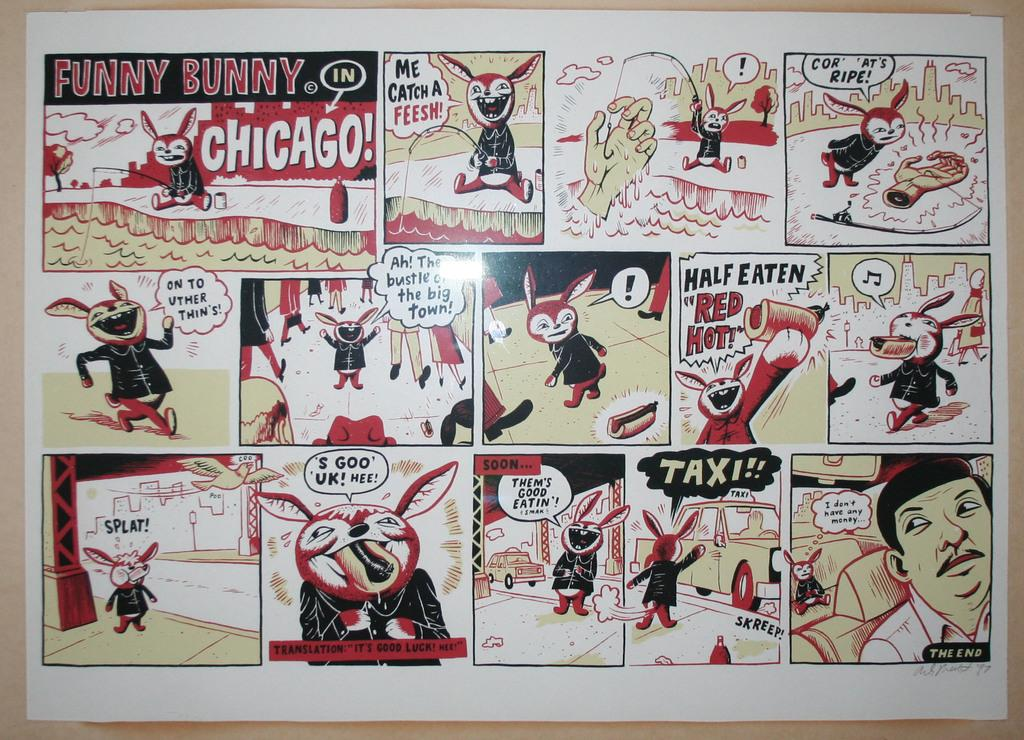<image>
Relay a brief, clear account of the picture shown. Comic strip of a rabbit and a man titled "Funny Bunny". 